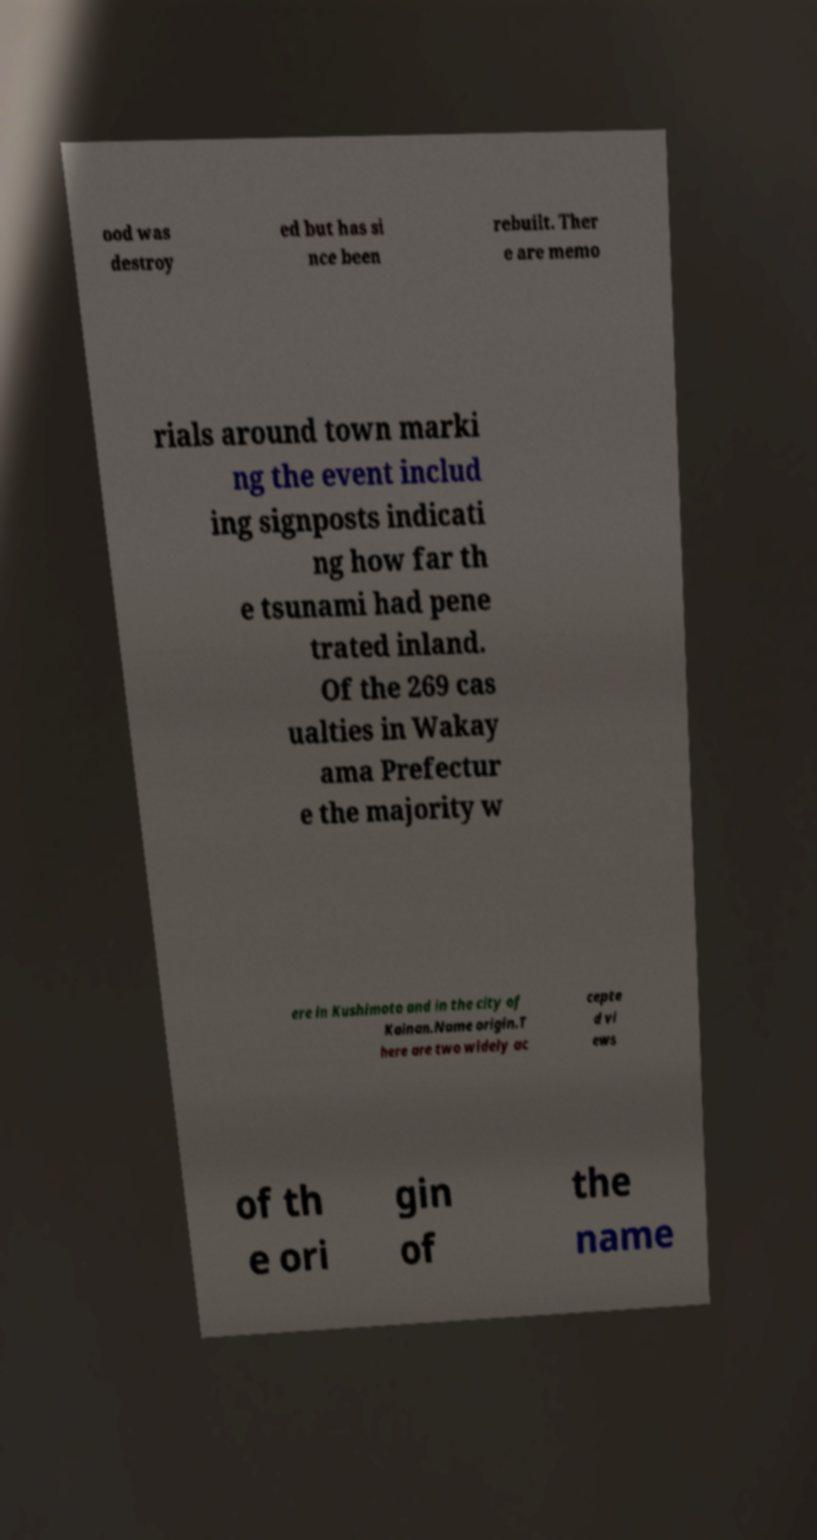There's text embedded in this image that I need extracted. Can you transcribe it verbatim? ood was destroy ed but has si nce been rebuilt. Ther e are memo rials around town marki ng the event includ ing signposts indicati ng how far th e tsunami had pene trated inland. Of the 269 cas ualties in Wakay ama Prefectur e the majority w ere in Kushimoto and in the city of Kainan.Name origin.T here are two widely ac cepte d vi ews of th e ori gin of the name 